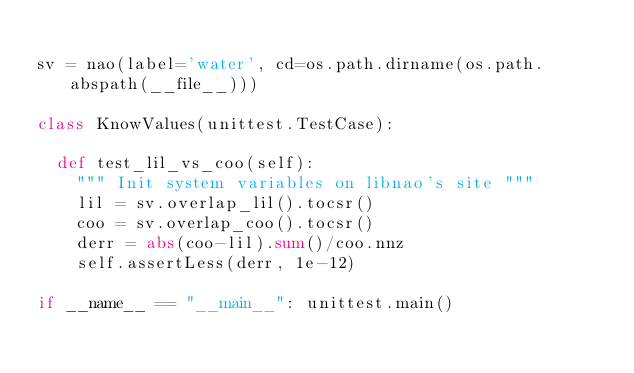<code> <loc_0><loc_0><loc_500><loc_500><_Python_>
sv = nao(label='water', cd=os.path.dirname(os.path.abspath(__file__)))

class KnowValues(unittest.TestCase):

  def test_lil_vs_coo(self):
    """ Init system variables on libnao's site """
    lil = sv.overlap_lil().tocsr()
    coo = sv.overlap_coo().tocsr()
    derr = abs(coo-lil).sum()/coo.nnz
    self.assertLess(derr, 1e-12)

if __name__ == "__main__": unittest.main()
</code> 